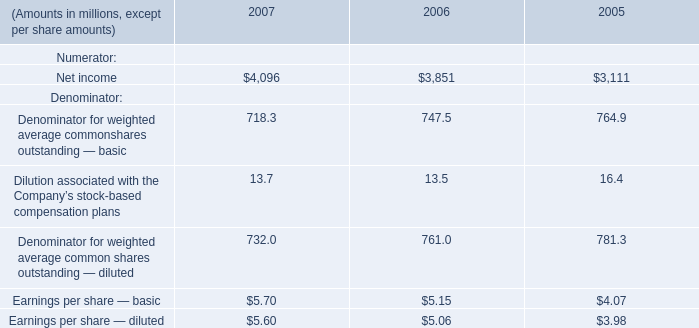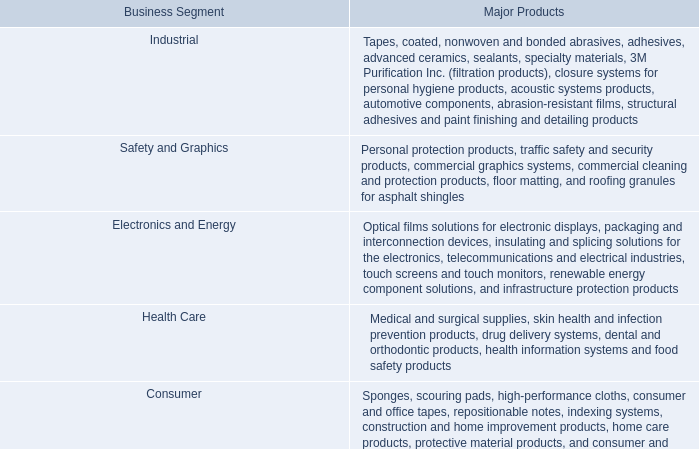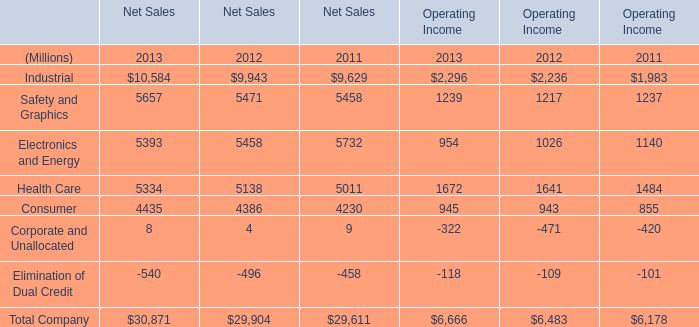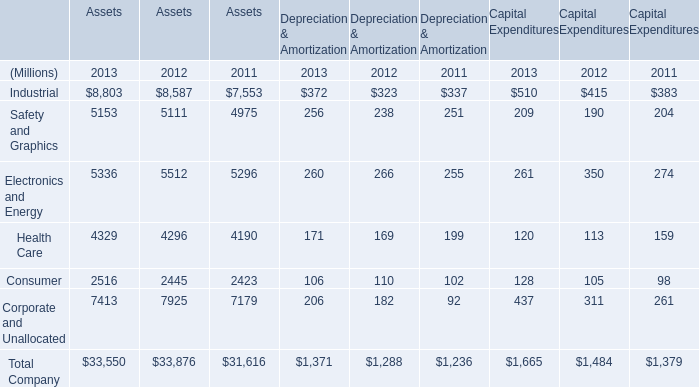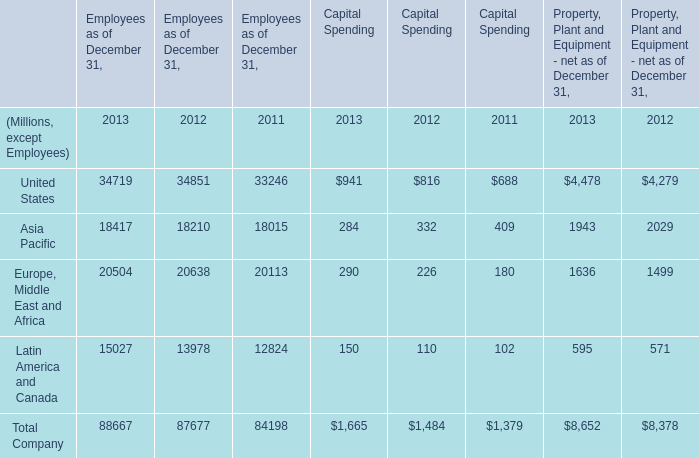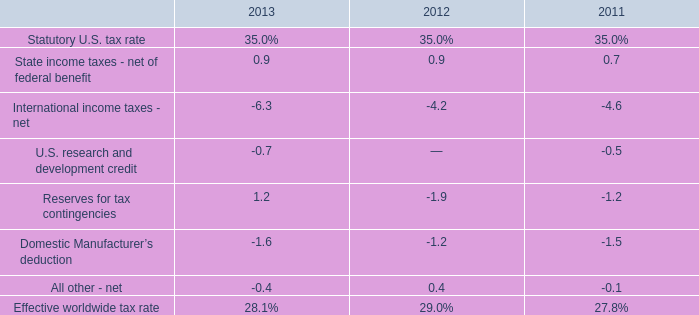what's the total amount of Consumer of Assets 2012, Safety and Graphics of Net Sales 2012, and Safety and Graphics of Operating Income 2011 ? 
Computations: ((2445.0 + 5471.0) + 1237.0)
Answer: 9153.0. 